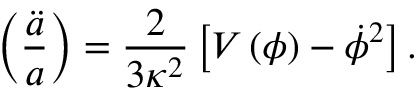Convert formula to latex. <formula><loc_0><loc_0><loc_500><loc_500>\left ( { \frac { \ddot { a } } { a } } \right ) = { \frac { 2 } { 3 \kappa ^ { 2 } } } \left [ V \left ( \phi \right ) - \dot { \phi } ^ { 2 } \right ] .</formula> 